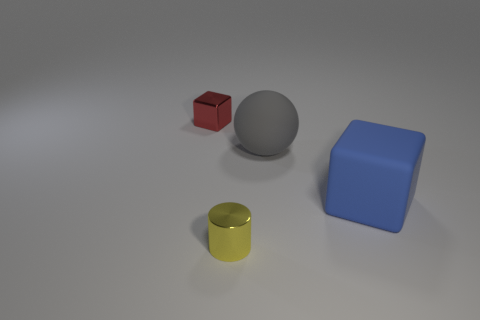Do the metallic thing that is on the right side of the metallic cube and the thing that is to the right of the gray ball have the same size?
Offer a terse response. No. There is a small thing that is left of the yellow thing; what shape is it?
Keep it short and to the point. Cube. What is the color of the rubber sphere?
Ensure brevity in your answer.  Gray. Is the size of the matte sphere the same as the block that is in front of the big rubber sphere?
Offer a very short reply. Yes. What number of shiny things are either yellow blocks or blue objects?
Offer a very short reply. 0. Is there anything else that is the same material as the red cube?
Keep it short and to the point. Yes. Do the large matte block and the tiny metallic thing that is behind the blue block have the same color?
Your answer should be very brief. No. The yellow shiny object has what shape?
Give a very brief answer. Cylinder. What is the size of the shiny object that is right of the small object that is behind the small object in front of the small cube?
Offer a terse response. Small. What number of other things are there of the same shape as the red metal thing?
Your answer should be very brief. 1. 